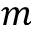Convert formula to latex. <formula><loc_0><loc_0><loc_500><loc_500>m</formula> 